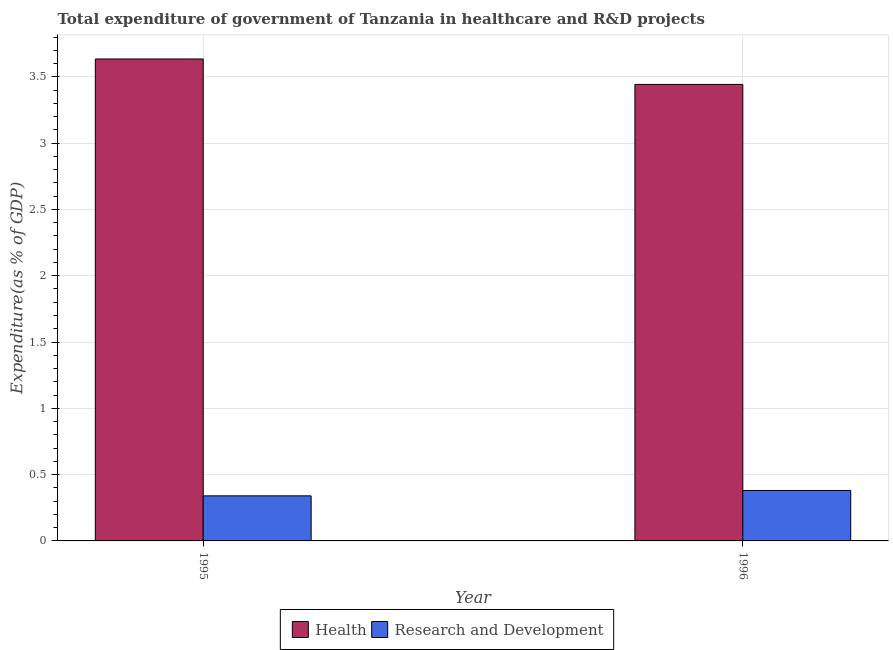Are the number of bars on each tick of the X-axis equal?
Your response must be concise. Yes. How many bars are there on the 2nd tick from the left?
Give a very brief answer. 2. In how many cases, is the number of bars for a given year not equal to the number of legend labels?
Your answer should be very brief. 0. What is the expenditure in healthcare in 1996?
Ensure brevity in your answer.  3.44. Across all years, what is the maximum expenditure in r&d?
Make the answer very short. 0.38. Across all years, what is the minimum expenditure in healthcare?
Offer a very short reply. 3.44. In which year was the expenditure in r&d maximum?
Offer a very short reply. 1996. In which year was the expenditure in r&d minimum?
Offer a terse response. 1995. What is the total expenditure in r&d in the graph?
Your answer should be compact. 0.72. What is the difference between the expenditure in healthcare in 1995 and that in 1996?
Provide a short and direct response. 0.19. What is the difference between the expenditure in r&d in 1995 and the expenditure in healthcare in 1996?
Offer a terse response. -0.04. What is the average expenditure in healthcare per year?
Your response must be concise. 3.54. In the year 1995, what is the difference between the expenditure in healthcare and expenditure in r&d?
Offer a very short reply. 0. In how many years, is the expenditure in r&d greater than 0.30000000000000004 %?
Keep it short and to the point. 2. What is the ratio of the expenditure in healthcare in 1995 to that in 1996?
Provide a succinct answer. 1.06. In how many years, is the expenditure in healthcare greater than the average expenditure in healthcare taken over all years?
Give a very brief answer. 1. What does the 1st bar from the left in 1996 represents?
Your answer should be very brief. Health. What does the 1st bar from the right in 1995 represents?
Provide a succinct answer. Research and Development. Are all the bars in the graph horizontal?
Your answer should be compact. No. How many years are there in the graph?
Offer a terse response. 2. What is the difference between two consecutive major ticks on the Y-axis?
Ensure brevity in your answer.  0.5. Does the graph contain any zero values?
Your answer should be very brief. No. How many legend labels are there?
Give a very brief answer. 2. How are the legend labels stacked?
Give a very brief answer. Horizontal. What is the title of the graph?
Make the answer very short. Total expenditure of government of Tanzania in healthcare and R&D projects. What is the label or title of the Y-axis?
Make the answer very short. Expenditure(as % of GDP). What is the Expenditure(as % of GDP) in Health in 1995?
Give a very brief answer. 3.63. What is the Expenditure(as % of GDP) of Research and Development in 1995?
Your response must be concise. 0.34. What is the Expenditure(as % of GDP) in Health in 1996?
Provide a short and direct response. 3.44. What is the Expenditure(as % of GDP) in Research and Development in 1996?
Give a very brief answer. 0.38. Across all years, what is the maximum Expenditure(as % of GDP) of Health?
Offer a terse response. 3.63. Across all years, what is the maximum Expenditure(as % of GDP) of Research and Development?
Your answer should be compact. 0.38. Across all years, what is the minimum Expenditure(as % of GDP) of Health?
Your answer should be very brief. 3.44. Across all years, what is the minimum Expenditure(as % of GDP) of Research and Development?
Your answer should be very brief. 0.34. What is the total Expenditure(as % of GDP) of Health in the graph?
Offer a terse response. 7.08. What is the total Expenditure(as % of GDP) in Research and Development in the graph?
Offer a very short reply. 0.72. What is the difference between the Expenditure(as % of GDP) in Health in 1995 and that in 1996?
Ensure brevity in your answer.  0.19. What is the difference between the Expenditure(as % of GDP) in Research and Development in 1995 and that in 1996?
Your answer should be very brief. -0.04. What is the difference between the Expenditure(as % of GDP) of Health in 1995 and the Expenditure(as % of GDP) of Research and Development in 1996?
Keep it short and to the point. 3.25. What is the average Expenditure(as % of GDP) of Health per year?
Ensure brevity in your answer.  3.54. What is the average Expenditure(as % of GDP) of Research and Development per year?
Ensure brevity in your answer.  0.36. In the year 1995, what is the difference between the Expenditure(as % of GDP) of Health and Expenditure(as % of GDP) of Research and Development?
Give a very brief answer. 3.29. In the year 1996, what is the difference between the Expenditure(as % of GDP) of Health and Expenditure(as % of GDP) of Research and Development?
Offer a terse response. 3.06. What is the ratio of the Expenditure(as % of GDP) in Health in 1995 to that in 1996?
Your response must be concise. 1.06. What is the ratio of the Expenditure(as % of GDP) of Research and Development in 1995 to that in 1996?
Your response must be concise. 0.89. What is the difference between the highest and the second highest Expenditure(as % of GDP) of Health?
Provide a short and direct response. 0.19. What is the difference between the highest and the second highest Expenditure(as % of GDP) of Research and Development?
Offer a terse response. 0.04. What is the difference between the highest and the lowest Expenditure(as % of GDP) in Health?
Offer a terse response. 0.19. What is the difference between the highest and the lowest Expenditure(as % of GDP) of Research and Development?
Your answer should be compact. 0.04. 